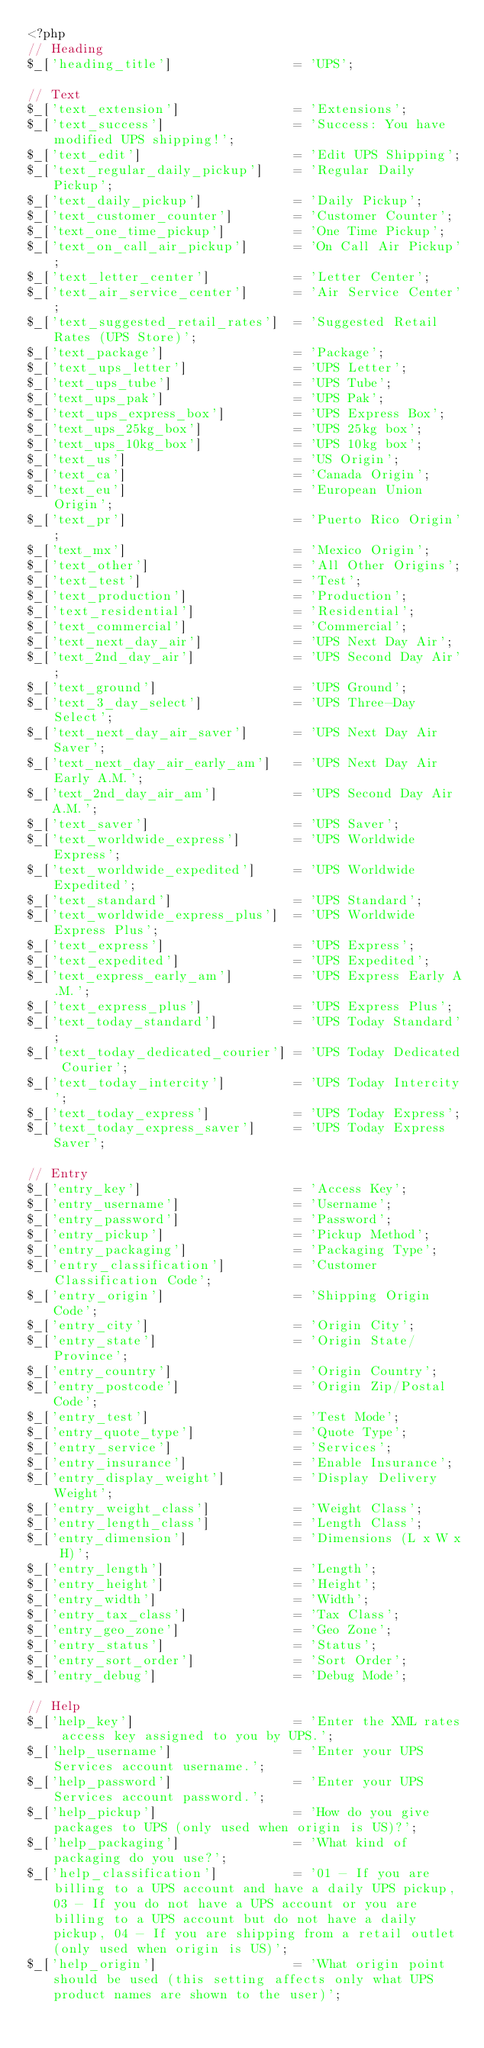<code> <loc_0><loc_0><loc_500><loc_500><_PHP_><?php
// Heading
$_['heading_title']                = 'UPS';

// Text
$_['text_extension']               = 'Extensions';
$_['text_success']                 = 'Success: You have modified UPS shipping!';
$_['text_edit']                    = 'Edit UPS Shipping';
$_['text_regular_daily_pickup']    = 'Regular Daily Pickup';
$_['text_daily_pickup']            = 'Daily Pickup';
$_['text_customer_counter']        = 'Customer Counter';
$_['text_one_time_pickup']         = 'One Time Pickup';
$_['text_on_call_air_pickup']      = 'On Call Air Pickup';
$_['text_letter_center']           = 'Letter Center';
$_['text_air_service_center']      = 'Air Service Center';
$_['text_suggested_retail_rates']  = 'Suggested Retail Rates (UPS Store)';
$_['text_package']                 = 'Package';
$_['text_ups_letter']              = 'UPS Letter';
$_['text_ups_tube']                = 'UPS Tube';
$_['text_ups_pak']                 = 'UPS Pak';
$_['text_ups_express_box']         = 'UPS Express Box';
$_['text_ups_25kg_box']            = 'UPS 25kg box';
$_['text_ups_10kg_box']            = 'UPS 10kg box';
$_['text_us']                      = 'US Origin';
$_['text_ca']                      = 'Canada Origin';
$_['text_eu']                      = 'European Union Origin';
$_['text_pr']                      = 'Puerto Rico Origin';
$_['text_mx']                      = 'Mexico Origin';
$_['text_other']                   = 'All Other Origins';
$_['text_test']                    = 'Test';
$_['text_production']              = 'Production';
$_['text_residential']             = 'Residential';
$_['text_commercial']              = 'Commercial';
$_['text_next_day_air']            = 'UPS Next Day Air';
$_['text_2nd_day_air']             = 'UPS Second Day Air';
$_['text_ground']                  = 'UPS Ground';
$_['text_3_day_select']            = 'UPS Three-Day Select';
$_['text_next_day_air_saver']      = 'UPS Next Day Air Saver';
$_['text_next_day_air_early_am']   = 'UPS Next Day Air Early A.M.';
$_['text_2nd_day_air_am']          = 'UPS Second Day Air A.M.';
$_['text_saver']                   = 'UPS Saver';
$_['text_worldwide_express']       = 'UPS Worldwide Express';
$_['text_worldwide_expedited']     = 'UPS Worldwide Expedited';
$_['text_standard']                = 'UPS Standard';
$_['text_worldwide_express_plus']  = 'UPS Worldwide Express Plus';
$_['text_express']                 = 'UPS Express';
$_['text_expedited']               = 'UPS Expedited';
$_['text_express_early_am']        = 'UPS Express Early A.M.';
$_['text_express_plus']            = 'UPS Express Plus';
$_['text_today_standard']          = 'UPS Today Standard';
$_['text_today_dedicated_courier'] = 'UPS Today Dedicated Courier';
$_['text_today_intercity']         = 'UPS Today Intercity';
$_['text_today_express']           = 'UPS Today Express';
$_['text_today_express_saver']     = 'UPS Today Express Saver';

// Entry
$_['entry_key']                    = 'Access Key';
$_['entry_username']               = 'Username';
$_['entry_password']               = 'Password';
$_['entry_pickup']                 = 'Pickup Method';
$_['entry_packaging']              = 'Packaging Type';
$_['entry_classification']         = 'Customer Classification Code';
$_['entry_origin']                 = 'Shipping Origin Code';
$_['entry_city']                   = 'Origin City';
$_['entry_state']                  = 'Origin State/Province';
$_['entry_country']                = 'Origin Country';
$_['entry_postcode']               = 'Origin Zip/Postal Code';
$_['entry_test']                   = 'Test Mode';
$_['entry_quote_type']             = 'Quote Type';
$_['entry_service']                = 'Services';
$_['entry_insurance']              = 'Enable Insurance';
$_['entry_display_weight']         = 'Display Delivery Weight';
$_['entry_weight_class']           = 'Weight Class';
$_['entry_length_class']           = 'Length Class';
$_['entry_dimension']              = 'Dimensions (L x W x H)';
$_['entry_length']                 = 'Length';
$_['entry_height']                 = 'Height';
$_['entry_width']                  = 'Width';
$_['entry_tax_class']              = 'Tax Class';
$_['entry_geo_zone']               = 'Geo Zone';
$_['entry_status']                 = 'Status';
$_['entry_sort_order']             = 'Sort Order';
$_['entry_debug']                  = 'Debug Mode';

// Help
$_['help_key']                     = 'Enter the XML rates access key assigned to you by UPS.';
$_['help_username']                = 'Enter your UPS Services account username.';
$_['help_password']                = 'Enter your UPS Services account password.';
$_['help_pickup']                  = 'How do you give packages to UPS (only used when origin is US)?';
$_['help_packaging']               = 'What kind of packaging do you use?';
$_['help_classification']          = '01 - If you are billing to a UPS account and have a daily UPS pickup, 03 - If you do not have a UPS account or you are billing to a UPS account but do not have a daily pickup, 04 - If you are shipping from a retail outlet (only used when origin is US)';
$_['help_origin']                  = 'What origin point should be used (this setting affects only what UPS product names are shown to the user)';</code> 